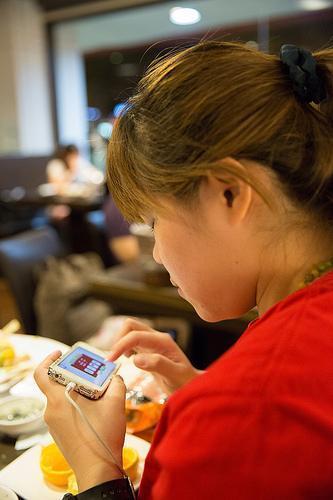How many girls are in focus?
Give a very brief answer. 1. 